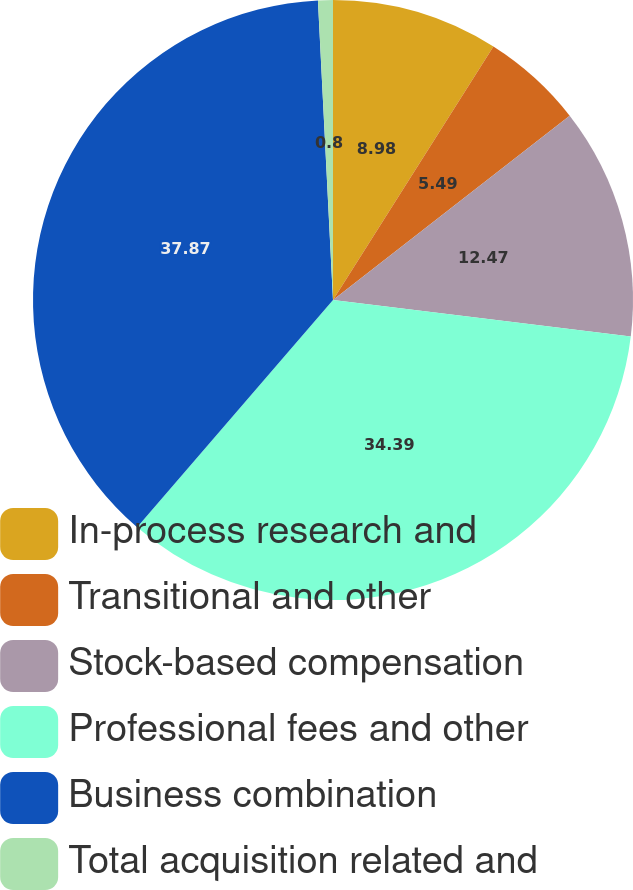Convert chart to OTSL. <chart><loc_0><loc_0><loc_500><loc_500><pie_chart><fcel>In-process research and<fcel>Transitional and other<fcel>Stock-based compensation<fcel>Professional fees and other<fcel>Business combination<fcel>Total acquisition related and<nl><fcel>8.98%<fcel>5.49%<fcel>12.47%<fcel>34.39%<fcel>37.88%<fcel>0.8%<nl></chart> 